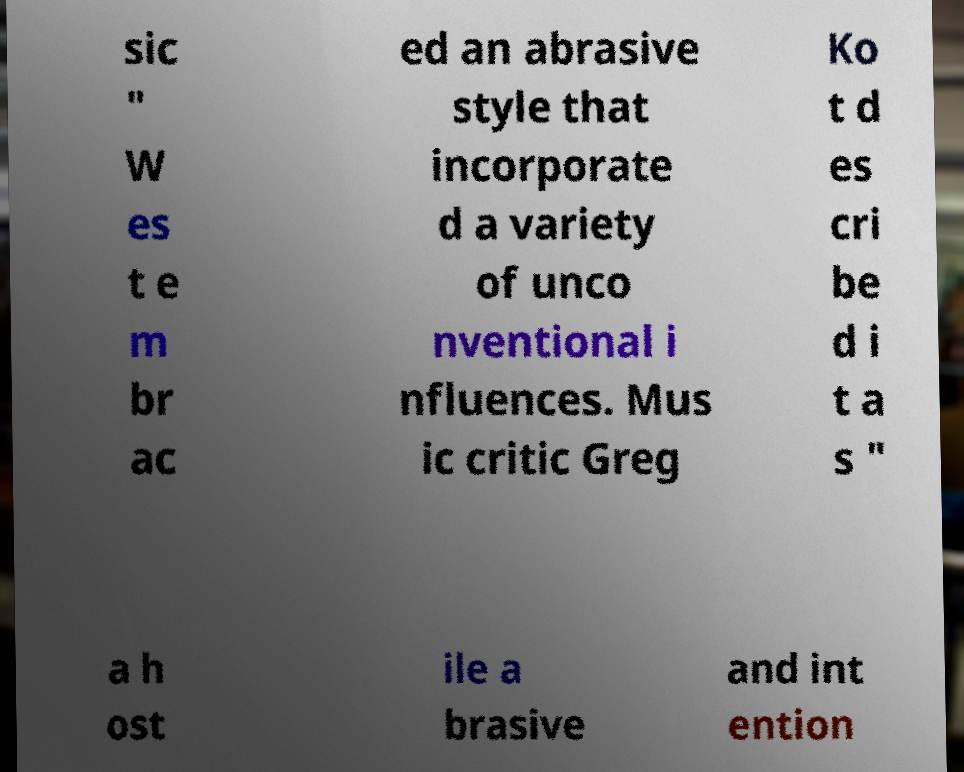Please read and relay the text visible in this image. What does it say? sic " W es t e m br ac ed an abrasive style that incorporate d a variety of unco nventional i nfluences. Mus ic critic Greg Ko t d es cri be d i t a s " a h ost ile a brasive and int ention 